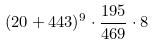Convert formula to latex. <formula><loc_0><loc_0><loc_500><loc_500>( 2 0 + 4 4 3 ) ^ { 9 } \cdot \frac { 1 9 5 } { 4 6 9 } \cdot 8</formula> 